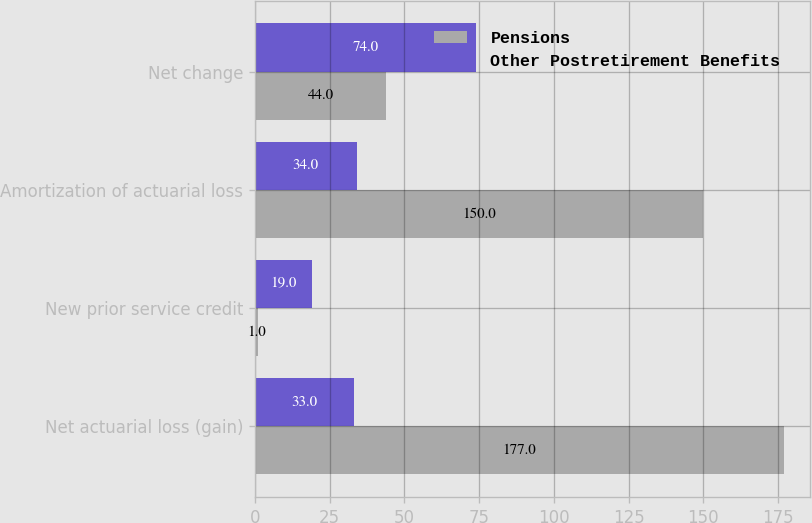Convert chart. <chart><loc_0><loc_0><loc_500><loc_500><stacked_bar_chart><ecel><fcel>Net actuarial loss (gain)<fcel>New prior service credit<fcel>Amortization of actuarial loss<fcel>Net change<nl><fcel>Pensions<fcel>177<fcel>1<fcel>150<fcel>44<nl><fcel>Other Postretirement Benefits<fcel>33<fcel>19<fcel>34<fcel>74<nl></chart> 